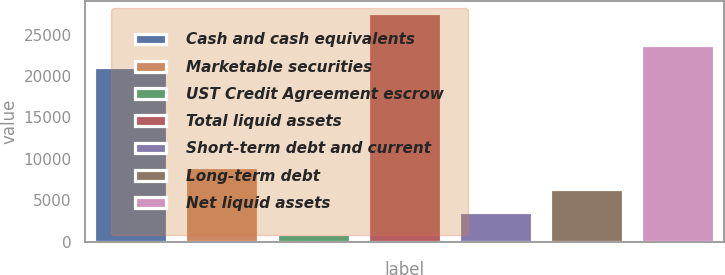<chart> <loc_0><loc_0><loc_500><loc_500><bar_chart><fcel>Cash and cash equivalents<fcel>Marketable securities<fcel>UST Credit Agreement escrow<fcel>Total liquid assets<fcel>Short-term debt and current<fcel>Long-term debt<fcel>Net liquid assets<nl><fcel>21061<fcel>8992.8<fcel>1008<fcel>27624<fcel>3669.6<fcel>6331.2<fcel>23722.6<nl></chart> 